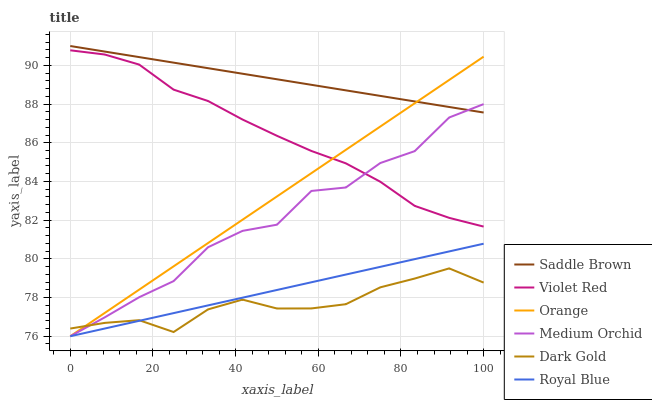Does Dark Gold have the minimum area under the curve?
Answer yes or no. Yes. Does Saddle Brown have the maximum area under the curve?
Answer yes or no. Yes. Does Medium Orchid have the minimum area under the curve?
Answer yes or no. No. Does Medium Orchid have the maximum area under the curve?
Answer yes or no. No. Is Royal Blue the smoothest?
Answer yes or no. Yes. Is Medium Orchid the roughest?
Answer yes or no. Yes. Is Dark Gold the smoothest?
Answer yes or no. No. Is Dark Gold the roughest?
Answer yes or no. No. Does Dark Gold have the lowest value?
Answer yes or no. No. Does Medium Orchid have the highest value?
Answer yes or no. No. Is Royal Blue less than Violet Red?
Answer yes or no. Yes. Is Violet Red greater than Royal Blue?
Answer yes or no. Yes. Does Royal Blue intersect Violet Red?
Answer yes or no. No. 